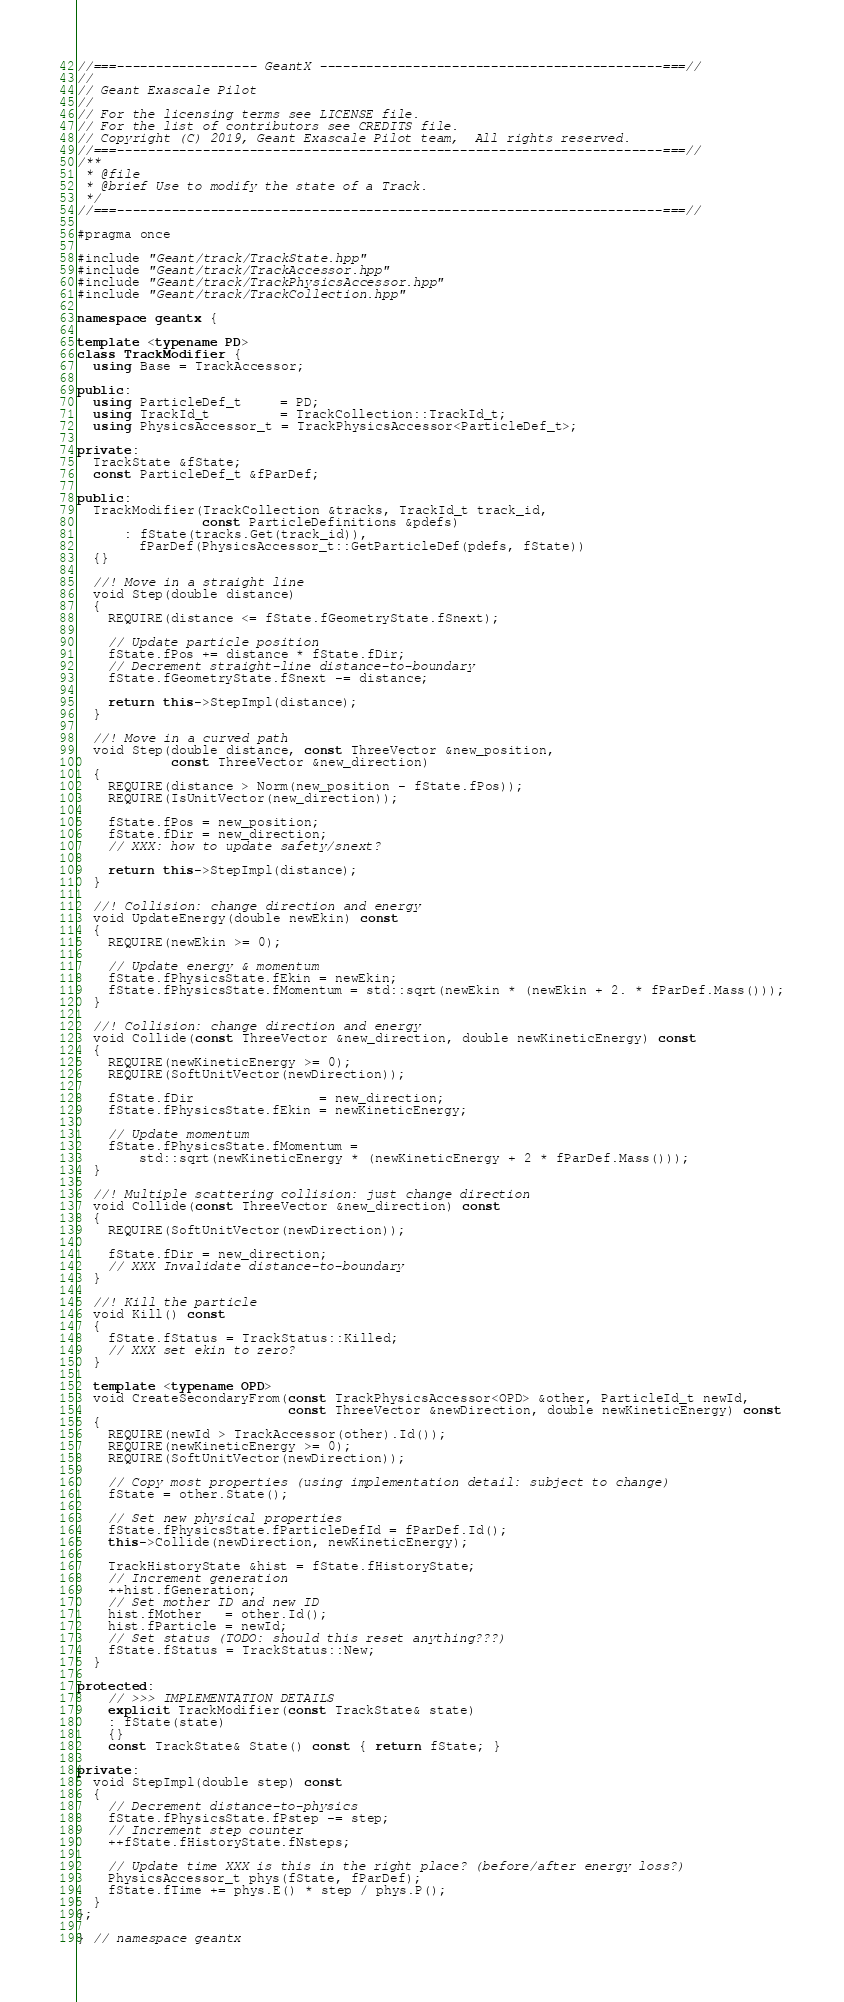<code> <loc_0><loc_0><loc_500><loc_500><_C++_>//===------------------ GeantX --------------------------------------------===//
//
// Geant Exascale Pilot
//
// For the licensing terms see LICENSE file.
// For the list of contributors see CREDITS file.
// Copyright (C) 2019, Geant Exascale Pilot team,  All rights reserved.
//===----------------------------------------------------------------------===//
/**
 * @file
 * @brief Use to modify the state of a Track.
 */
//===----------------------------------------------------------------------===//

#pragma once

#include "Geant/track/TrackState.hpp"
#include "Geant/track/TrackAccessor.hpp"
#include "Geant/track/TrackPhysicsAccessor.hpp"
#include "Geant/track/TrackCollection.hpp"

namespace geantx {

template <typename PD>
class TrackModifier {
  using Base = TrackAccessor;

public:
  using ParticleDef_t     = PD;
  using TrackId_t         = TrackCollection::TrackId_t;
  using PhysicsAccessor_t = TrackPhysicsAccessor<ParticleDef_t>;

private:
  TrackState &fState;
  const ParticleDef_t &fParDef;

public:
  TrackModifier(TrackCollection &tracks, TrackId_t track_id,
                const ParticleDefinitions &pdefs)
      : fState(tracks.Get(track_id)),
        fParDef(PhysicsAccessor_t::GetParticleDef(pdefs, fState))
  {}

  //! Move in a straight line
  void Step(double distance)
  {
    REQUIRE(distance <= fState.fGeometryState.fSnext);

    // Update particle position
    fState.fPos += distance * fState.fDir;
    // Decrement straight-line distance-to-boundary
    fState.fGeometryState.fSnext -= distance;

    return this->StepImpl(distance);
  }

  //! Move in a curved path
  void Step(double distance, const ThreeVector &new_position,
            const ThreeVector &new_direction)
  {
    REQUIRE(distance > Norm(new_position - fState.fPos));
    REQUIRE(IsUnitVector(new_direction));

    fState.fPos = new_position;
    fState.fDir = new_direction;
    // XXX: how to update safety/snext?

    return this->StepImpl(distance);
  }

  //! Collision: change direction and energy
  void UpdateEnergy(double newEkin) const
  {
    REQUIRE(newEkin >= 0);

    // Update energy & momentum
    fState.fPhysicsState.fEkin = newEkin;
    fState.fPhysicsState.fMomentum = std::sqrt(newEkin * (newEkin + 2. * fParDef.Mass()));
  }

  //! Collision: change direction and energy
  void Collide(const ThreeVector &new_direction, double newKineticEnergy) const
  {
    REQUIRE(newKineticEnergy >= 0);
    REQUIRE(SoftUnitVector(newDirection));

    fState.fDir                = new_direction;
    fState.fPhysicsState.fEkin = newKineticEnergy;

    // Update momentum
    fState.fPhysicsState.fMomentum =
        std::sqrt(newKineticEnergy * (newKineticEnergy + 2 * fParDef.Mass()));
  }

  //! Multiple scattering collision: just change direction
  void Collide(const ThreeVector &new_direction) const
  {
    REQUIRE(SoftUnitVector(newDirection));

    fState.fDir = new_direction;
    // XXX Invalidate distance-to-boundary
  }

  //! Kill the particle
  void Kill() const
  {
    fState.fStatus = TrackStatus::Killed;
    // XXX set ekin to zero?
  }

  template <typename OPD>
  void CreateSecondaryFrom(const TrackPhysicsAccessor<OPD> &other, ParticleId_t newId,
                           const ThreeVector &newDirection, double newKineticEnergy) const
  {
    REQUIRE(newId > TrackAccessor(other).Id());
    REQUIRE(newKineticEnergy >= 0);
    REQUIRE(SoftUnitVector(newDirection));

    // Copy most properties (using implementation detail: subject to change)
    fState = other.State();

    // Set new physical properties
    fState.fPhysicsState.fParticleDefId = fParDef.Id();
    this->Collide(newDirection, newKineticEnergy);

    TrackHistoryState &hist = fState.fHistoryState;
    // Increment generation
    ++hist.fGeneration;
    // Set mother ID and new ID
    hist.fMother   = other.Id();
    hist.fParticle = newId;
    // Set status (TODO: should this reset anything???)
    fState.fStatus = TrackStatus::New;
  }

protected:
    // >>> IMPLEMENTATION DETAILS
    explicit TrackModifier(const TrackState& state)
    : fState(state)
    {}
    const TrackState& State() const { return fState; }

private:
  void StepImpl(double step) const
  {
    // Decrement distance-to-physics
    fState.fPhysicsState.fPstep -= step;
    // Increment step counter
    ++fState.fHistoryState.fNsteps;

    // Update time XXX is this in the right place? (before/after energy loss?)
    PhysicsAccessor_t phys(fState, fParDef);
    fState.fTime += phys.E() * step / phys.P();
  }
};

} // namespace geantx
</code> 